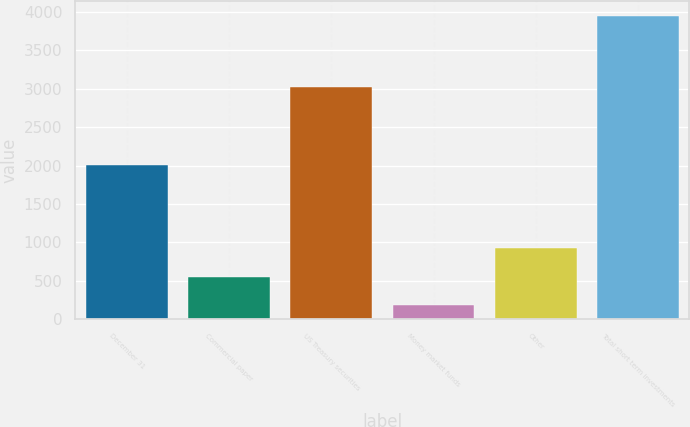Convert chart to OTSL. <chart><loc_0><loc_0><loc_500><loc_500><bar_chart><fcel>December 31<fcel>Commercial paper<fcel>US Treasury securities<fcel>Money market funds<fcel>Other<fcel>Total short term investments<nl><fcel>2009<fcel>556<fcel>3025<fcel>179<fcel>933<fcel>3949<nl></chart> 